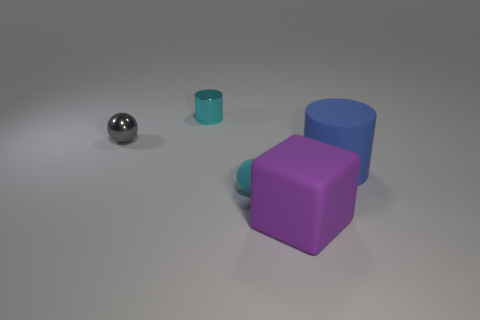What is the material of the other tiny object that is the same shape as the cyan matte thing?
Offer a terse response. Metal. Is the color of the tiny object on the left side of the tiny cyan metallic thing the same as the rubber ball?
Keep it short and to the point. No. Does the large blue object have the same material as the cyan thing that is behind the tiny gray thing?
Ensure brevity in your answer.  No. What shape is the small thing that is on the left side of the cyan shiny object?
Keep it short and to the point. Sphere. How many other things are there of the same material as the gray sphere?
Give a very brief answer. 1. How big is the blue rubber cylinder?
Make the answer very short. Large. How many other objects are the same color as the cube?
Give a very brief answer. 0. The object that is both behind the tiny rubber object and in front of the small gray object is what color?
Offer a terse response. Blue. How many large red things are there?
Provide a short and direct response. 0. Do the big purple cube and the small gray object have the same material?
Offer a very short reply. No. 